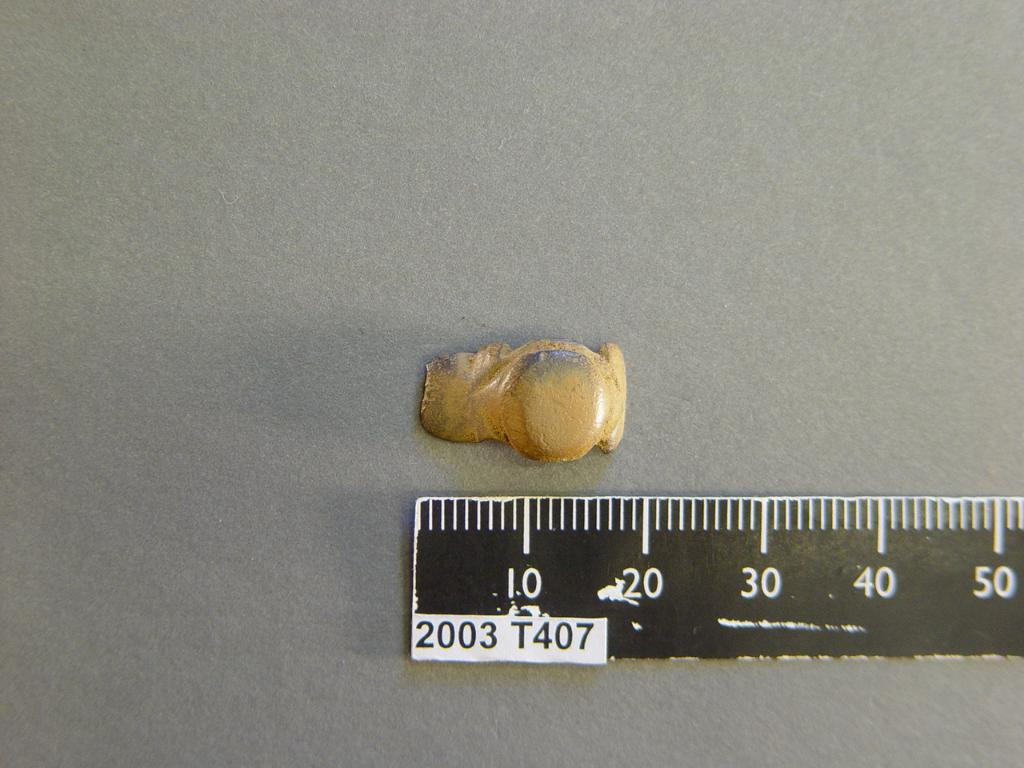<image>
Give a short and clear explanation of the subsequent image. A ruler with the number 2003 on it is next to a piece of puddy. 